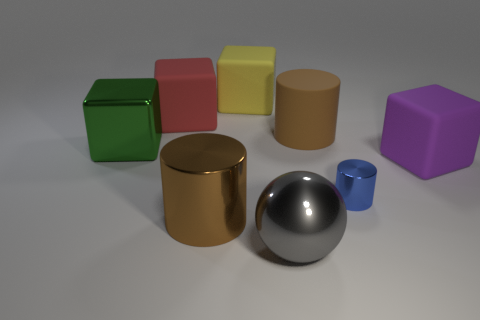Subtract all matte cylinders. How many cylinders are left? 2 Add 1 green shiny cylinders. How many objects exist? 9 Subtract all blue cylinders. How many cylinders are left? 2 Subtract all spheres. How many objects are left? 7 Subtract all blue cubes. How many yellow spheres are left? 0 Subtract all brown matte things. Subtract all big rubber things. How many objects are left? 3 Add 6 large purple objects. How many large purple objects are left? 7 Add 5 big green blocks. How many big green blocks exist? 6 Subtract 0 brown balls. How many objects are left? 8 Subtract 1 cylinders. How many cylinders are left? 2 